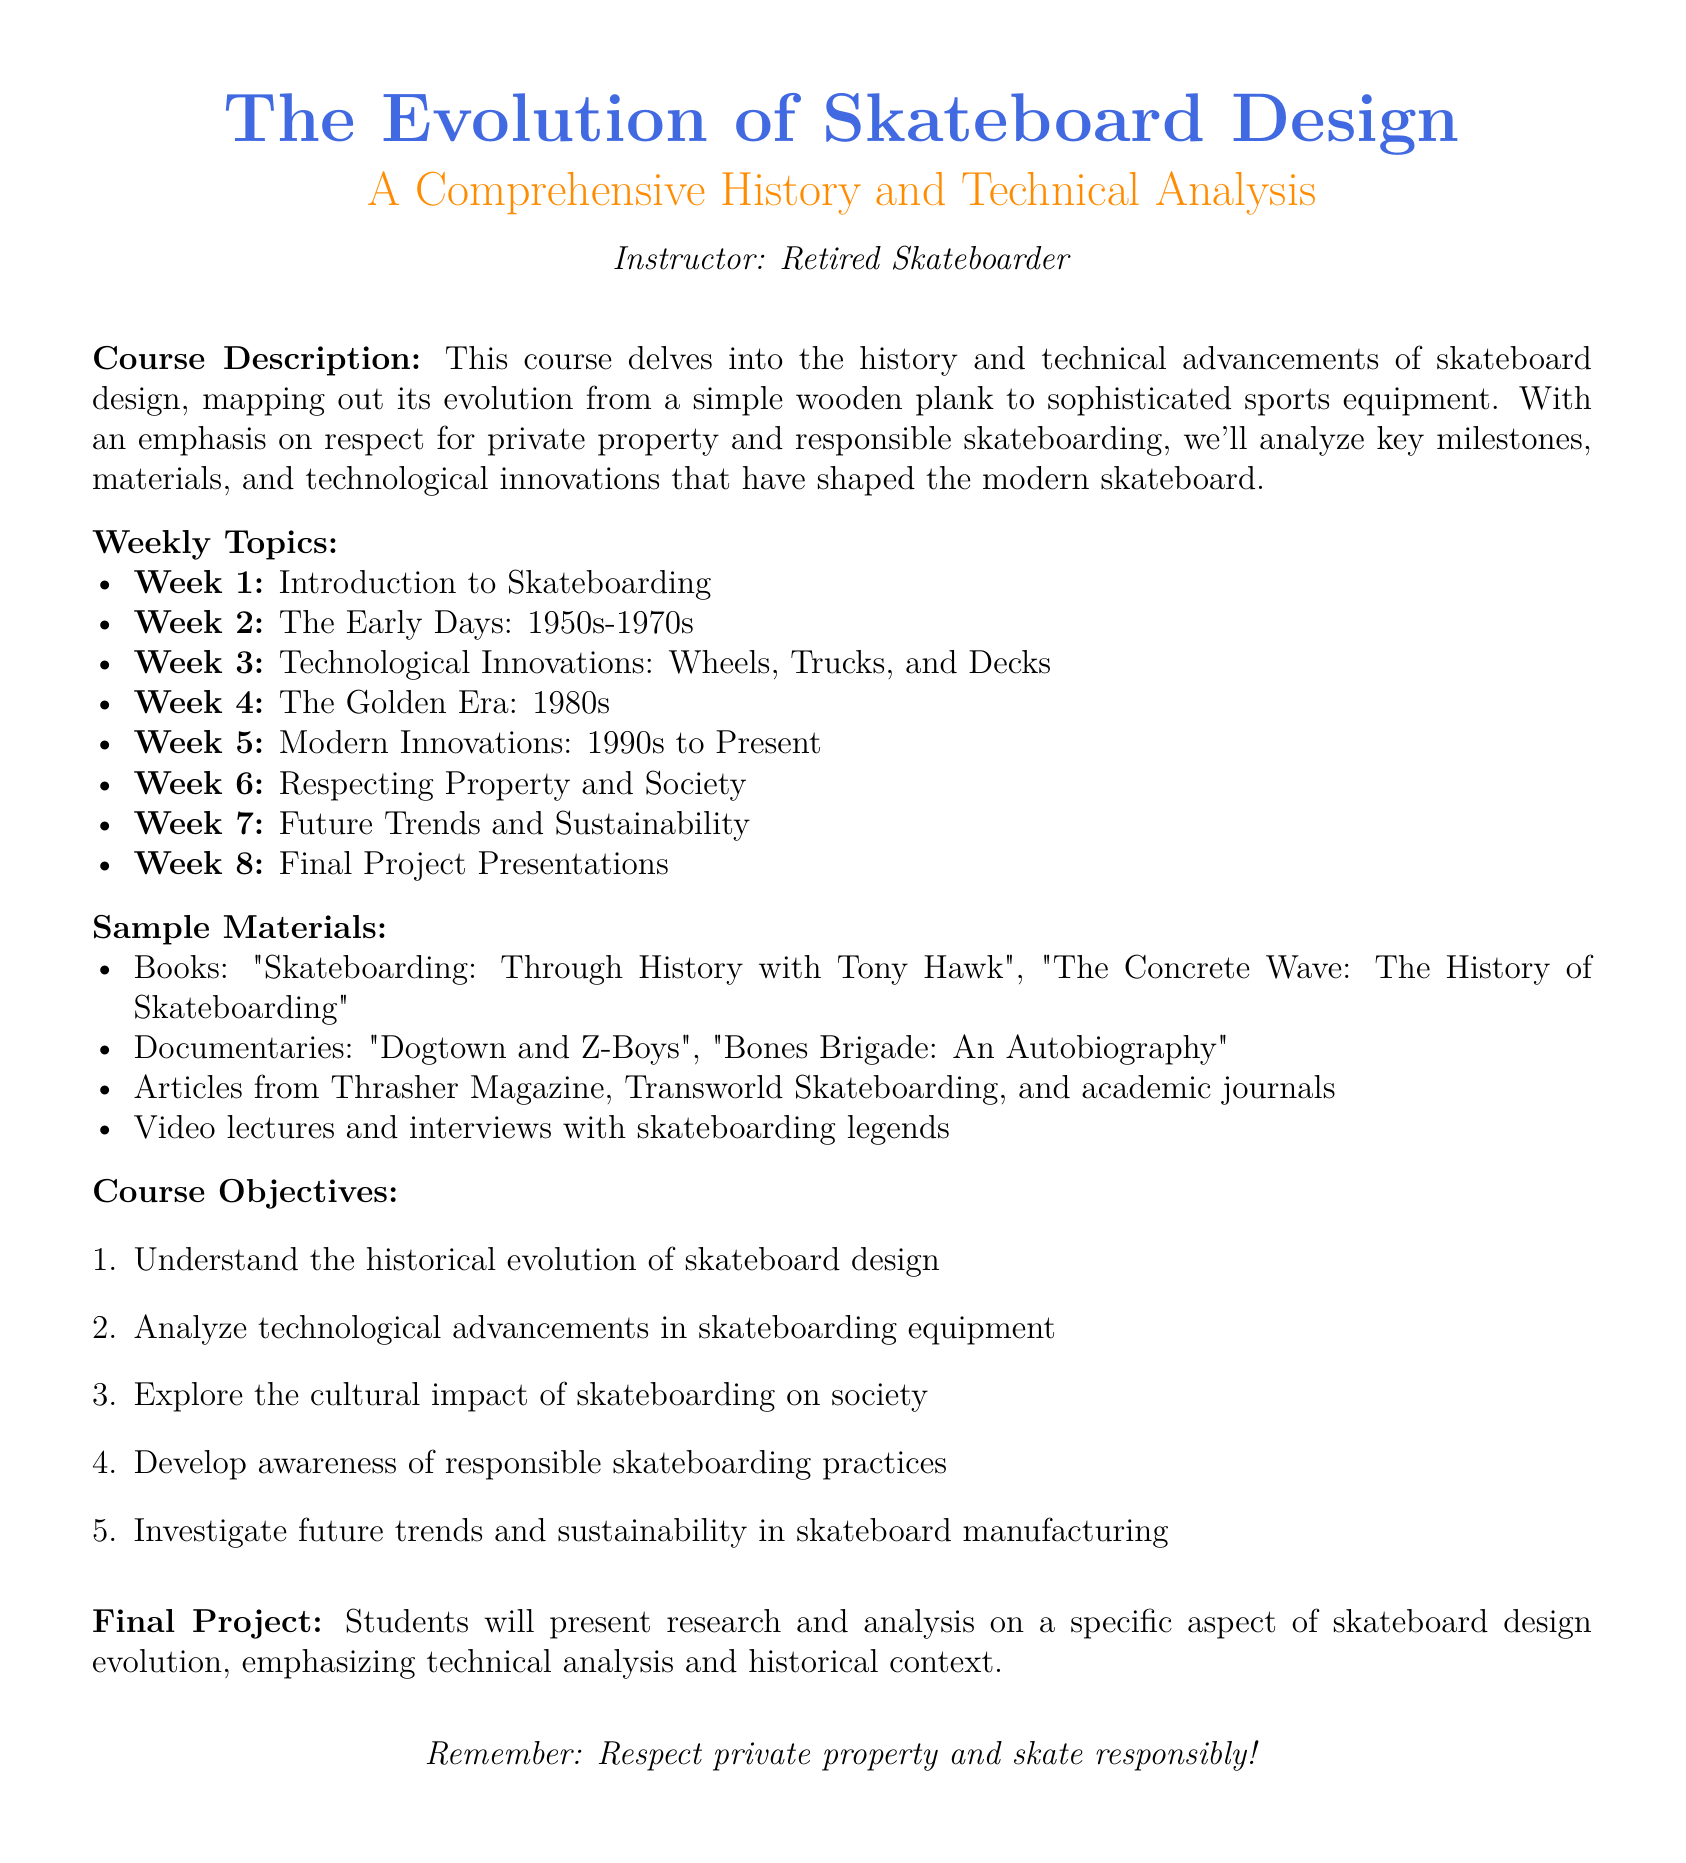What is the course title? The course title is explicitly noted at the beginning of the document.
Answer: The Evolution of Skateboard Design Who is the instructor? The instructor's name is given in the course description section.
Answer: Retired Skateboarder What decade is referred to in Week 2? The decade for Week 2 is specified directly in the weekly topics section.
Answer: 1950s-1970s How many weeks are covered in the course? The total number of weeks is indicated by the number of topics listed.
Answer: 8 What is one of the sample books listed? A specific sample book is mentioned in the materials section.
Answer: Skateboarding: Through History with Tony Hawk What is a key focus of Week 6? The focus for Week 6 is outlined as part of the weekly topics.
Answer: Respecting Property and Society What type of final project is assigned? The nature of the final project is clearly stated in the final project section.
Answer: Research and analysis What is one objective of the course? One of the objectives is listed numerically in the course objectives section.
Answer: Understand the historical evolution of skateboard design What color is used for the section titles? The color for the section titles is described in the formatting section.
Answer: Skateblue 